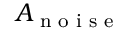<formula> <loc_0><loc_0><loc_500><loc_500>A _ { n o i s e }</formula> 